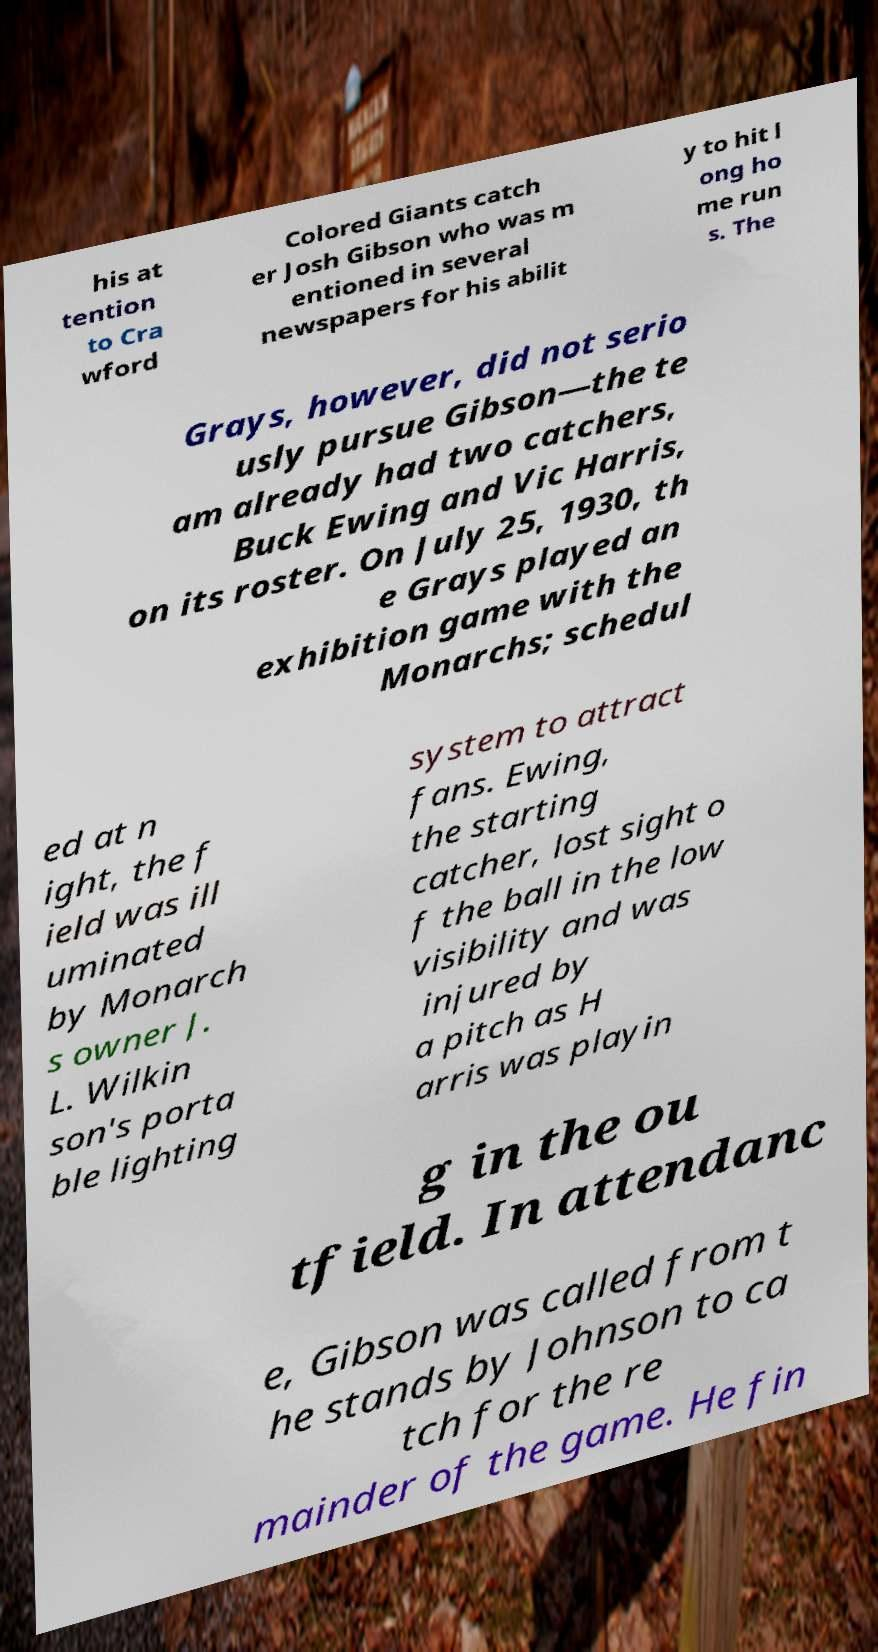Please identify and transcribe the text found in this image. his at tention to Cra wford Colored Giants catch er Josh Gibson who was m entioned in several newspapers for his abilit y to hit l ong ho me run s. The Grays, however, did not serio usly pursue Gibson—the te am already had two catchers, Buck Ewing and Vic Harris, on its roster. On July 25, 1930, th e Grays played an exhibition game with the Monarchs; schedul ed at n ight, the f ield was ill uminated by Monarch s owner J. L. Wilkin son's porta ble lighting system to attract fans. Ewing, the starting catcher, lost sight o f the ball in the low visibility and was injured by a pitch as H arris was playin g in the ou tfield. In attendanc e, Gibson was called from t he stands by Johnson to ca tch for the re mainder of the game. He fin 